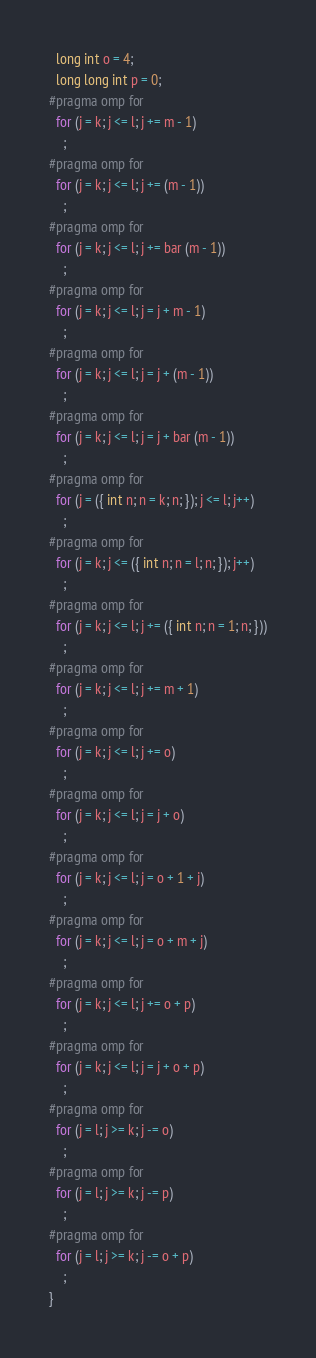Convert code to text. <code><loc_0><loc_0><loc_500><loc_500><_C_>  long int o = 4;
  long long int p = 0;
#pragma omp for
  for (j = k; j <= l; j += m - 1)
    ;
#pragma omp for
  for (j = k; j <= l; j += (m - 1))
    ;
#pragma omp for
  for (j = k; j <= l; j += bar (m - 1))
    ;
#pragma omp for
  for (j = k; j <= l; j = j + m - 1)
    ;
#pragma omp for
  for (j = k; j <= l; j = j + (m - 1))
    ;
#pragma omp for
  for (j = k; j <= l; j = j + bar (m - 1))
    ;
#pragma omp for
  for (j = ({ int n; n = k; n; }); j <= l; j++)
    ;
#pragma omp for
  for (j = k; j <= ({ int n; n = l; n; }); j++)
    ;
#pragma omp for
  for (j = k; j <= l; j += ({ int n; n = 1; n; }))
    ;
#pragma omp for
  for (j = k; j <= l; j += m + 1)
    ;
#pragma omp for
  for (j = k; j <= l; j += o)
    ;
#pragma omp for
  for (j = k; j <= l; j = j + o)
    ;
#pragma omp for
  for (j = k; j <= l; j = o + 1 + j)
    ;
#pragma omp for
  for (j = k; j <= l; j = o + m + j)
    ;
#pragma omp for
  for (j = k; j <= l; j += o + p)
    ;
#pragma omp for
  for (j = k; j <= l; j = j + o + p)
    ;
#pragma omp for
  for (j = l; j >= k; j -= o)
    ;
#pragma omp for
  for (j = l; j >= k; j -= p)
    ;
#pragma omp for
  for (j = l; j >= k; j -= o + p)
    ;
}
</code> 